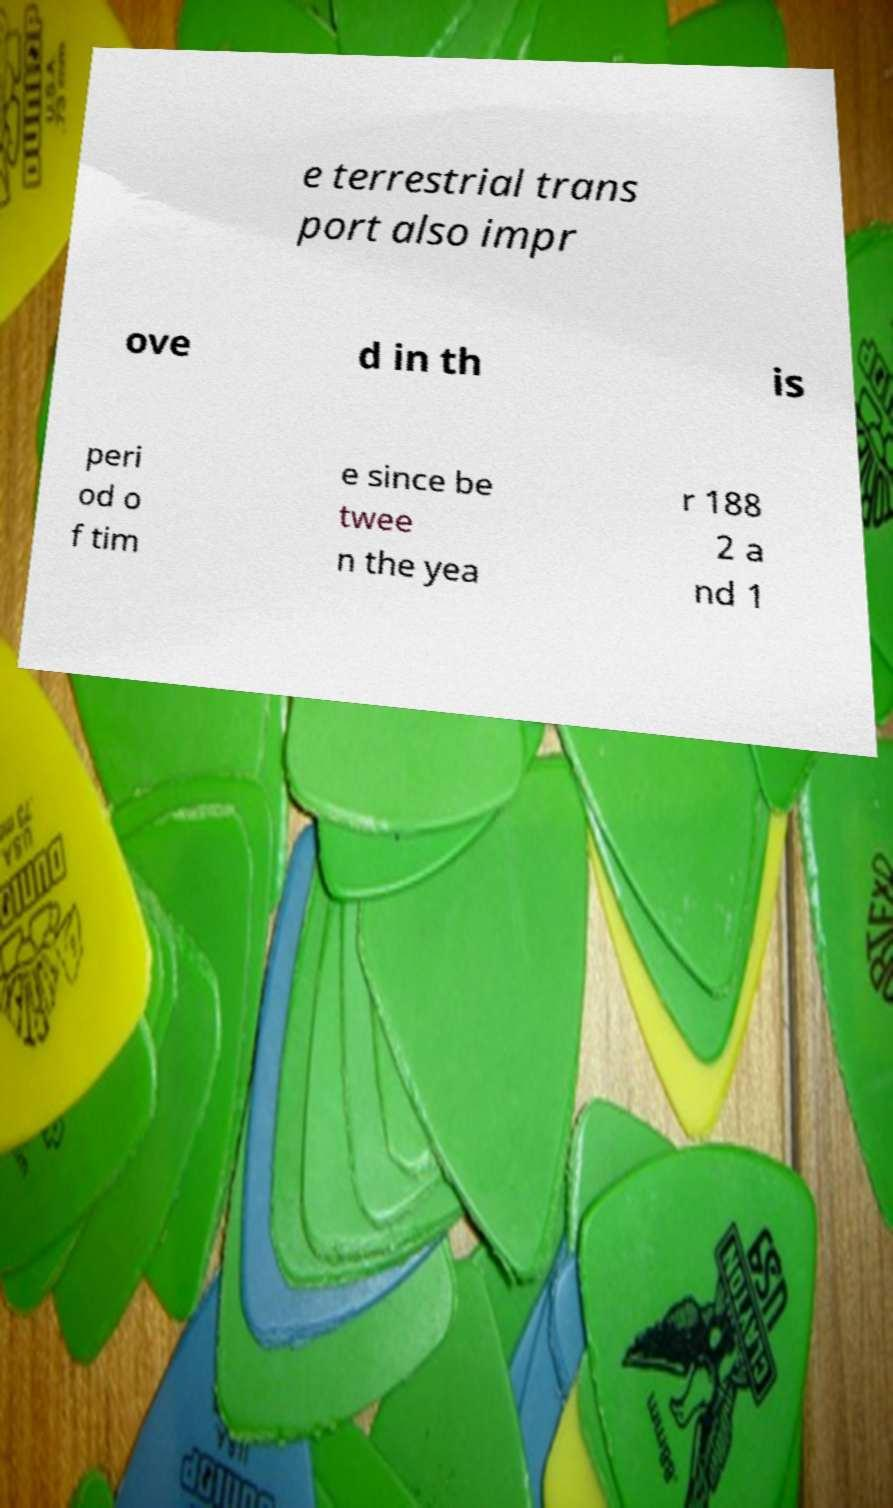For documentation purposes, I need the text within this image transcribed. Could you provide that? e terrestrial trans port also impr ove d in th is peri od o f tim e since be twee n the yea r 188 2 a nd 1 